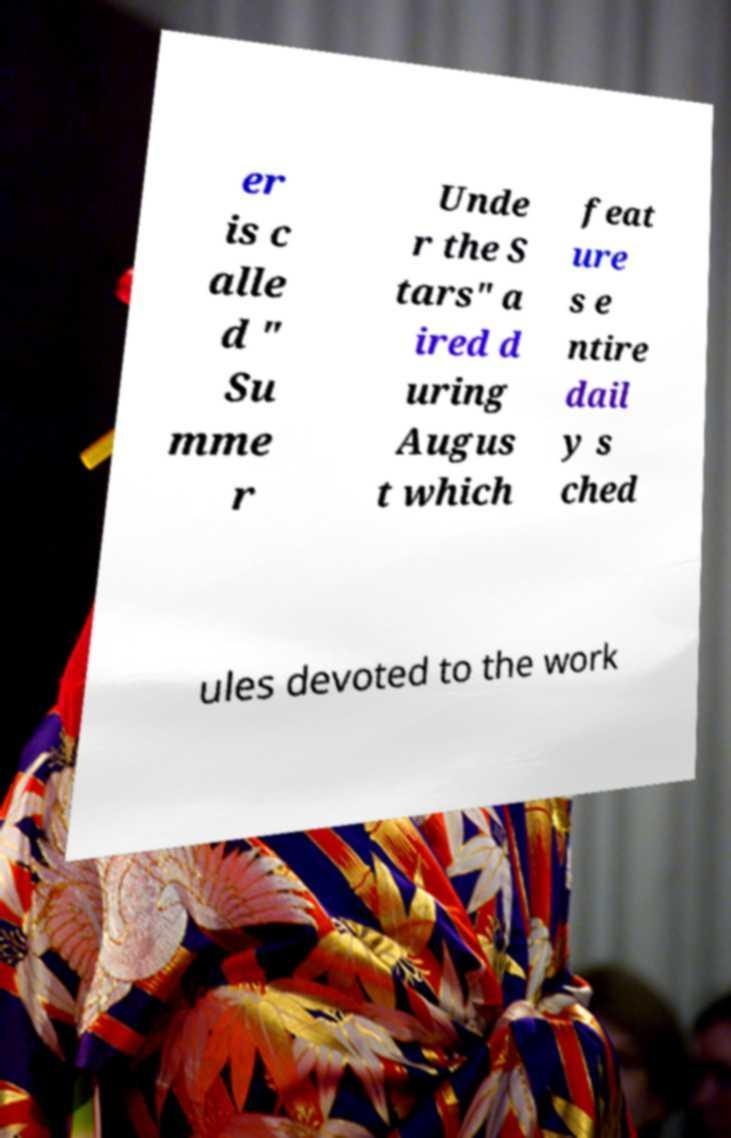Please identify and transcribe the text found in this image. er is c alle d " Su mme r Unde r the S tars" a ired d uring Augus t which feat ure s e ntire dail y s ched ules devoted to the work 